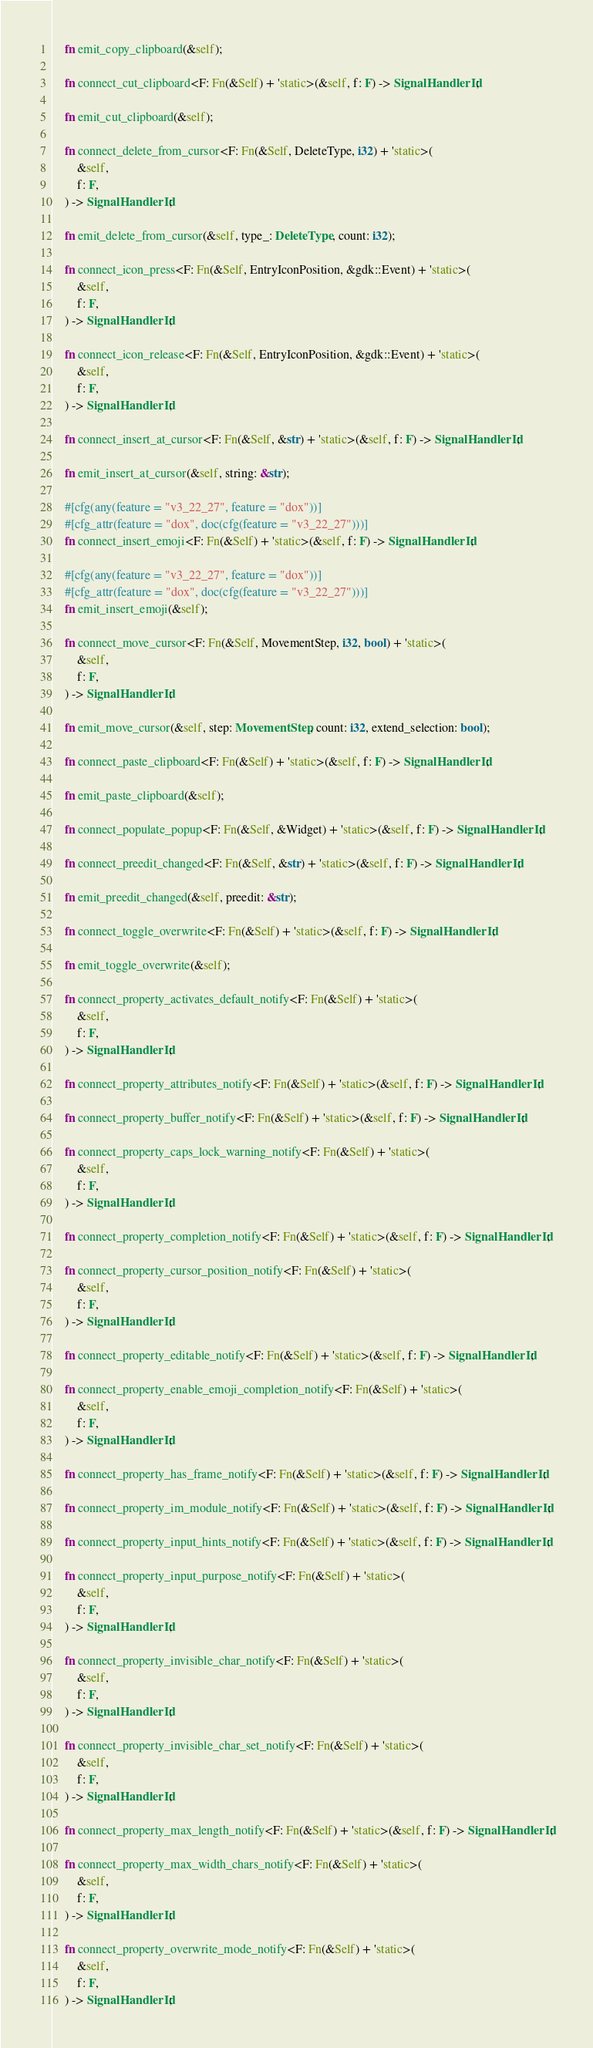Convert code to text. <code><loc_0><loc_0><loc_500><loc_500><_Rust_>
    fn emit_copy_clipboard(&self);

    fn connect_cut_clipboard<F: Fn(&Self) + 'static>(&self, f: F) -> SignalHandlerId;

    fn emit_cut_clipboard(&self);

    fn connect_delete_from_cursor<F: Fn(&Self, DeleteType, i32) + 'static>(
        &self,
        f: F,
    ) -> SignalHandlerId;

    fn emit_delete_from_cursor(&self, type_: DeleteType, count: i32);

    fn connect_icon_press<F: Fn(&Self, EntryIconPosition, &gdk::Event) + 'static>(
        &self,
        f: F,
    ) -> SignalHandlerId;

    fn connect_icon_release<F: Fn(&Self, EntryIconPosition, &gdk::Event) + 'static>(
        &self,
        f: F,
    ) -> SignalHandlerId;

    fn connect_insert_at_cursor<F: Fn(&Self, &str) + 'static>(&self, f: F) -> SignalHandlerId;

    fn emit_insert_at_cursor(&self, string: &str);

    #[cfg(any(feature = "v3_22_27", feature = "dox"))]
    #[cfg_attr(feature = "dox", doc(cfg(feature = "v3_22_27")))]
    fn connect_insert_emoji<F: Fn(&Self) + 'static>(&self, f: F) -> SignalHandlerId;

    #[cfg(any(feature = "v3_22_27", feature = "dox"))]
    #[cfg_attr(feature = "dox", doc(cfg(feature = "v3_22_27")))]
    fn emit_insert_emoji(&self);

    fn connect_move_cursor<F: Fn(&Self, MovementStep, i32, bool) + 'static>(
        &self,
        f: F,
    ) -> SignalHandlerId;

    fn emit_move_cursor(&self, step: MovementStep, count: i32, extend_selection: bool);

    fn connect_paste_clipboard<F: Fn(&Self) + 'static>(&self, f: F) -> SignalHandlerId;

    fn emit_paste_clipboard(&self);

    fn connect_populate_popup<F: Fn(&Self, &Widget) + 'static>(&self, f: F) -> SignalHandlerId;

    fn connect_preedit_changed<F: Fn(&Self, &str) + 'static>(&self, f: F) -> SignalHandlerId;

    fn emit_preedit_changed(&self, preedit: &str);

    fn connect_toggle_overwrite<F: Fn(&Self) + 'static>(&self, f: F) -> SignalHandlerId;

    fn emit_toggle_overwrite(&self);

    fn connect_property_activates_default_notify<F: Fn(&Self) + 'static>(
        &self,
        f: F,
    ) -> SignalHandlerId;

    fn connect_property_attributes_notify<F: Fn(&Self) + 'static>(&self, f: F) -> SignalHandlerId;

    fn connect_property_buffer_notify<F: Fn(&Self) + 'static>(&self, f: F) -> SignalHandlerId;

    fn connect_property_caps_lock_warning_notify<F: Fn(&Self) + 'static>(
        &self,
        f: F,
    ) -> SignalHandlerId;

    fn connect_property_completion_notify<F: Fn(&Self) + 'static>(&self, f: F) -> SignalHandlerId;

    fn connect_property_cursor_position_notify<F: Fn(&Self) + 'static>(
        &self,
        f: F,
    ) -> SignalHandlerId;

    fn connect_property_editable_notify<F: Fn(&Self) + 'static>(&self, f: F) -> SignalHandlerId;

    fn connect_property_enable_emoji_completion_notify<F: Fn(&Self) + 'static>(
        &self,
        f: F,
    ) -> SignalHandlerId;

    fn connect_property_has_frame_notify<F: Fn(&Self) + 'static>(&self, f: F) -> SignalHandlerId;

    fn connect_property_im_module_notify<F: Fn(&Self) + 'static>(&self, f: F) -> SignalHandlerId;

    fn connect_property_input_hints_notify<F: Fn(&Self) + 'static>(&self, f: F) -> SignalHandlerId;

    fn connect_property_input_purpose_notify<F: Fn(&Self) + 'static>(
        &self,
        f: F,
    ) -> SignalHandlerId;

    fn connect_property_invisible_char_notify<F: Fn(&Self) + 'static>(
        &self,
        f: F,
    ) -> SignalHandlerId;

    fn connect_property_invisible_char_set_notify<F: Fn(&Self) + 'static>(
        &self,
        f: F,
    ) -> SignalHandlerId;

    fn connect_property_max_length_notify<F: Fn(&Self) + 'static>(&self, f: F) -> SignalHandlerId;

    fn connect_property_max_width_chars_notify<F: Fn(&Self) + 'static>(
        &self,
        f: F,
    ) -> SignalHandlerId;

    fn connect_property_overwrite_mode_notify<F: Fn(&Self) + 'static>(
        &self,
        f: F,
    ) -> SignalHandlerId;
</code> 